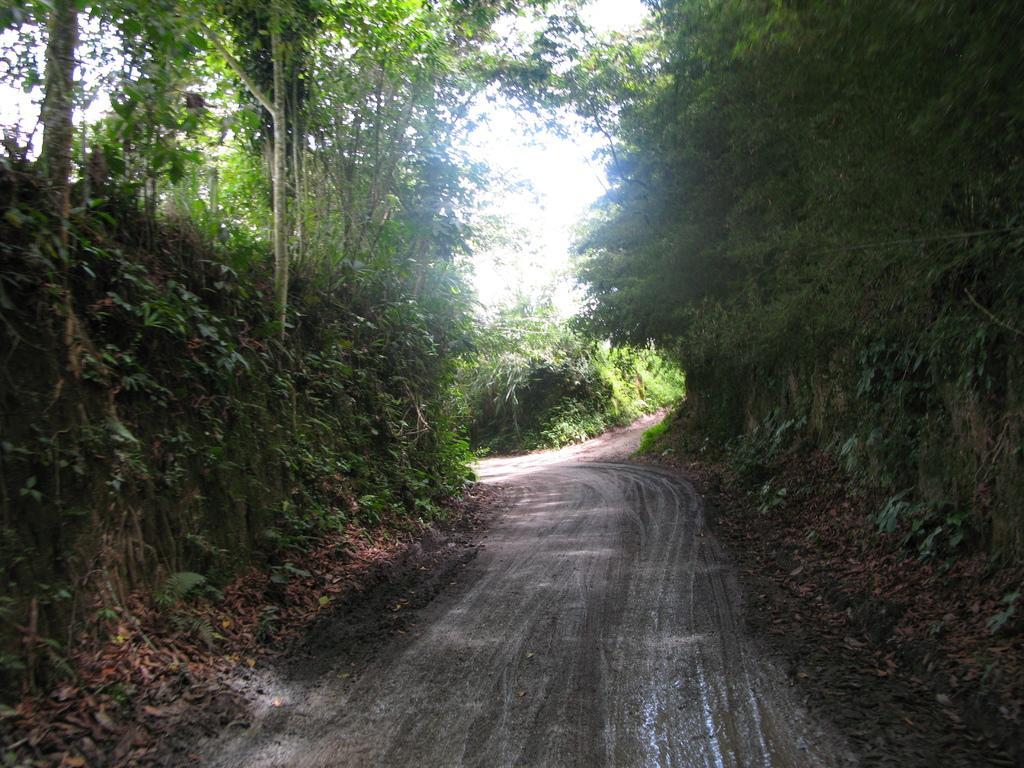Could you give a brief overview of what you see in this image? In this image I can see trees, plants and a road. In the background I can see the sky. 